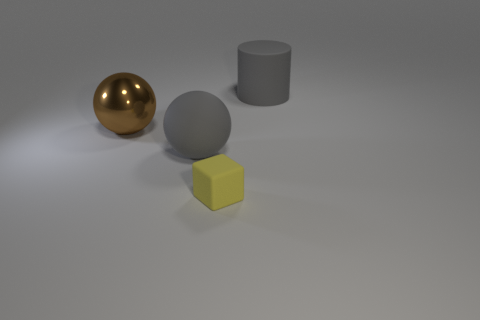Are there fewer big metal things that are in front of the small yellow rubber object than gray rubber balls?
Give a very brief answer. Yes. Does the rubber cylinder have the same color as the big matte sphere?
Offer a terse response. Yes. What size is the metal object?
Ensure brevity in your answer.  Large. What number of big matte things have the same color as the large rubber cylinder?
Keep it short and to the point. 1. Are there any large gray spheres that are to the left of the tiny yellow block that is left of the matte object to the right of the small yellow matte object?
Make the answer very short. Yes. What is the shape of the brown shiny object that is the same size as the gray matte cylinder?
Make the answer very short. Sphere. How many big things are green cylinders or metal objects?
Offer a terse response. 1. The large sphere that is made of the same material as the big cylinder is what color?
Your answer should be very brief. Gray. Do the large gray rubber thing that is on the right side of the gray sphere and the matte thing that is in front of the big gray rubber ball have the same shape?
Your response must be concise. No. What number of metal objects are small yellow things or purple cylinders?
Give a very brief answer. 0. 